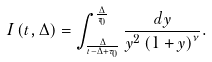Convert formula to latex. <formula><loc_0><loc_0><loc_500><loc_500>I \left ( t , \Delta \right ) = \int _ { \frac { \Delta } { t - \Delta + \tau _ { 0 } } } ^ { \frac { \Delta } { \tau _ { 0 } } } \frac { d y } { y ^ { 2 } \left ( 1 + y \right ) ^ { \nu } } .</formula> 